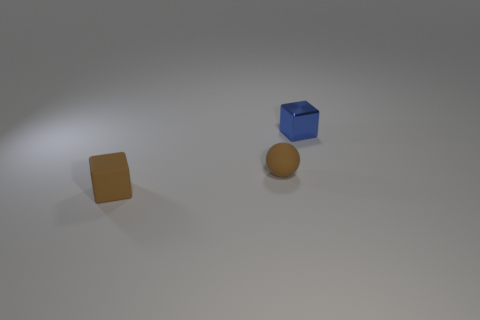Add 2 small balls. How many objects exist? 5 Subtract all balls. How many objects are left? 2 Subtract all tiny brown rubber spheres. Subtract all tiny matte cubes. How many objects are left? 1 Add 3 small things. How many small things are left? 6 Add 1 things. How many things exist? 4 Subtract 0 purple blocks. How many objects are left? 3 